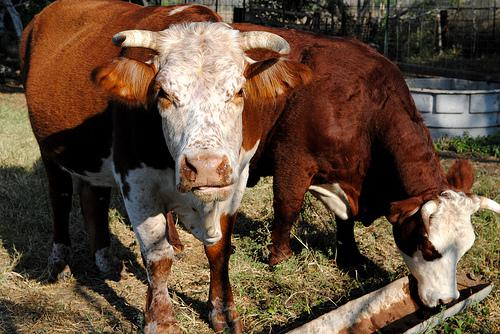Question: how many cows are there?
Choices:
A. One.
B. Three.
C. Four.
D. Two.
Answer with the letter. Answer: D Question: who is with the cows?
Choices:
A. The farmer.
B. No one.
C. The farmer's wife.
D. A farmhand.
Answer with the letter. Answer: B Question: what direction is the cow looking?
Choices:
A. Ahead.
B. Behind her.
C. To the right.
D. To the left.
Answer with the letter. Answer: A Question: what animals are these?
Choices:
A. Cows.
B. Horses.
C. Chickens.
D. Pigs.
Answer with the letter. Answer: A 